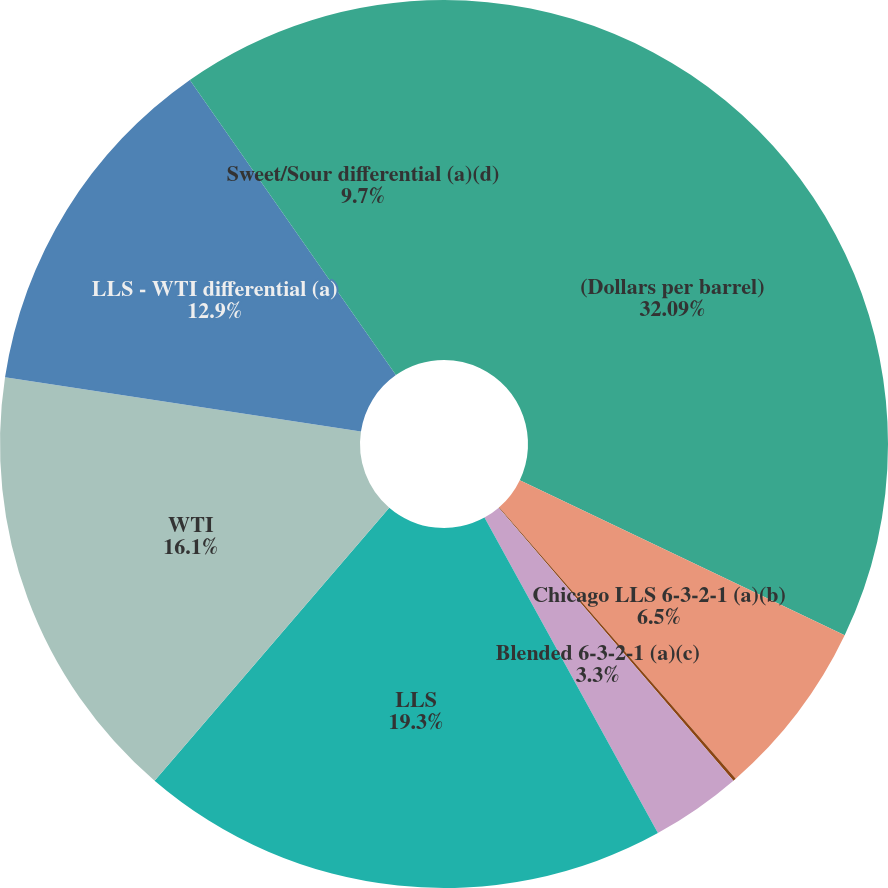<chart> <loc_0><loc_0><loc_500><loc_500><pie_chart><fcel>(Dollars per barrel)<fcel>Chicago LLS 6-3-2-1 (a)(b)<fcel>USGC LLS 6-3-2-1 (a)<fcel>Blended 6-3-2-1 (a)(c)<fcel>LLS<fcel>WTI<fcel>LLS - WTI differential (a)<fcel>Sweet/Sour differential (a)(d)<nl><fcel>32.09%<fcel>6.5%<fcel>0.11%<fcel>3.3%<fcel>19.3%<fcel>16.1%<fcel>12.9%<fcel>9.7%<nl></chart> 